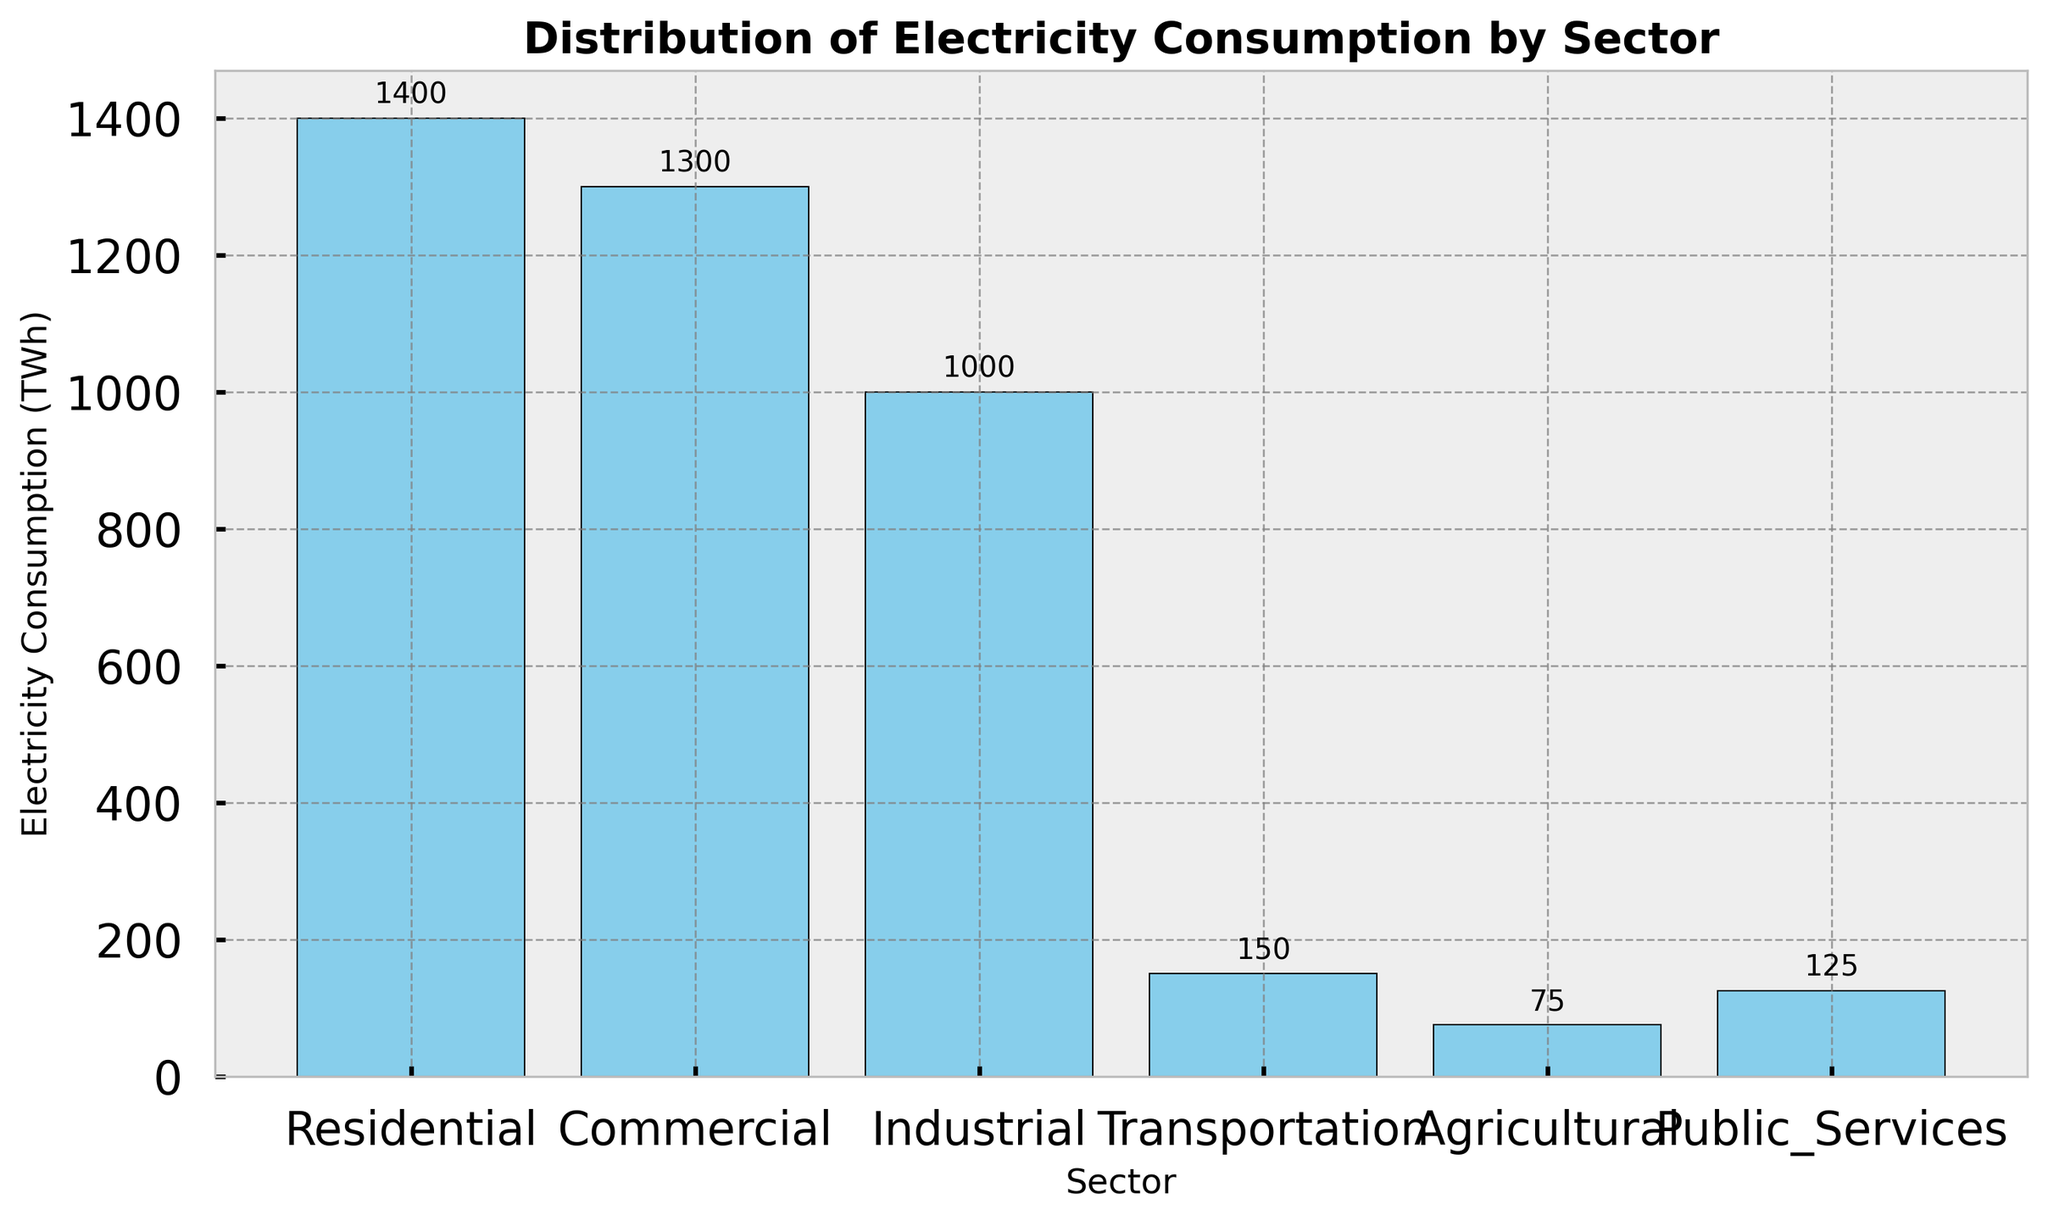What sector has the highest electricity consumption? The figure shows multiple sectors and their respective electricity consumption in TWh. By looking at the heights of the bars, the Residential sector has the tallest bar, meaning it has the highest consumption.
Answer: Residential Which sector consumes the least electricity? The figure displays the electricity consumption across various sectors. The shortest bar corresponds to the Agricultural sector, indicating it has the least consumption.
Answer: Agricultural How much more electricity does the Residential sector consume compared to the Industrial sector? The Residential sector consumes 1400 TWh, and the Industrial sector consumes 1000 TWh. The difference is calculated by subtracting the Industrial consumption from the Residential consumption (1400 - 1000).
Answer: 400 TWh What is the total electricity consumption of the Residential and Commercial sectors combined? The Residential sector consumes 1400 TWh and the Commercial sector consumes 1300 TWh. Adding these two values together gives the combined total (1400 + 1300).
Answer: 2700 TWh Which sector consumes more electricity: Transportation or Public Services? By comparing the heights of the bars for these two sectors, the Transportation sector consumes 150 TWh, and the Public Services sector consumes 125 TWh. 150 TWh is higher than 125 TWh.
Answer: Transportation What is the average electricity consumption across all sectors? The electricity consumptions are: 1400, 1300, 1000, 150, 75, and 125 TWh. Summing these values gives a total of 4050 TWh. Dividing by the number of sectors (6) gives the average (4050 / 6).
Answer: 675 TWh Which three sectors consume the most electricity? Observing the three tallest bars, the sectors are Residential (1400 TWh), Commercial (1300 TWh), and Industrial (1000 TWh). These are the sectors with the highest consumption.
Answer: Residential, Commercial, Industrial What is the combined electricity consumption of the Transportation and Agricultural sectors? The Transportation sector consumes 150 TWh, and the Agricultural sector consumes 75 TWh. Adding these values together gives (150 + 75).
Answer: 225 TWh How much more electricity does the Residential sector consume compared to all the non-Residential sectors combined? The Residential sector consumes 1400 TWh. The non-Residential sectors' total consumption is 3650 TWh (sum of 1300, 1000, 150, 75, and 125). The difference is (1400 - 3650).
Answer: 2250 TWh 